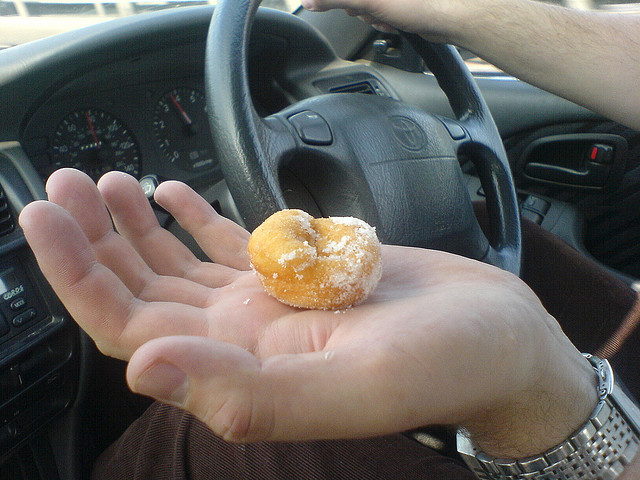<image>What is this cars make? I am not sure what the make of the car is. It could be either Toyota or Nissan. What is this cars make? I am not sure what is this car's make. It can be either 'toyota' or 'nissan'. 